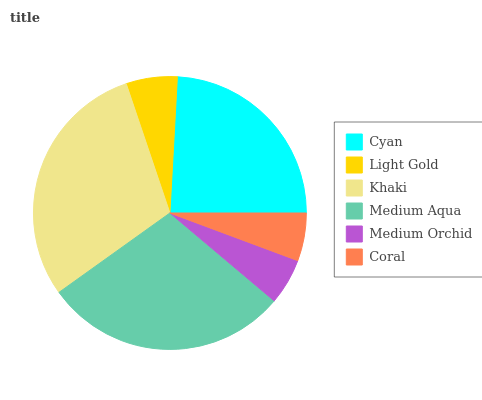Is Medium Orchid the minimum?
Answer yes or no. Yes. Is Khaki the maximum?
Answer yes or no. Yes. Is Light Gold the minimum?
Answer yes or no. No. Is Light Gold the maximum?
Answer yes or no. No. Is Cyan greater than Light Gold?
Answer yes or no. Yes. Is Light Gold less than Cyan?
Answer yes or no. Yes. Is Light Gold greater than Cyan?
Answer yes or no. No. Is Cyan less than Light Gold?
Answer yes or no. No. Is Cyan the high median?
Answer yes or no. Yes. Is Light Gold the low median?
Answer yes or no. Yes. Is Khaki the high median?
Answer yes or no. No. Is Cyan the low median?
Answer yes or no. No. 